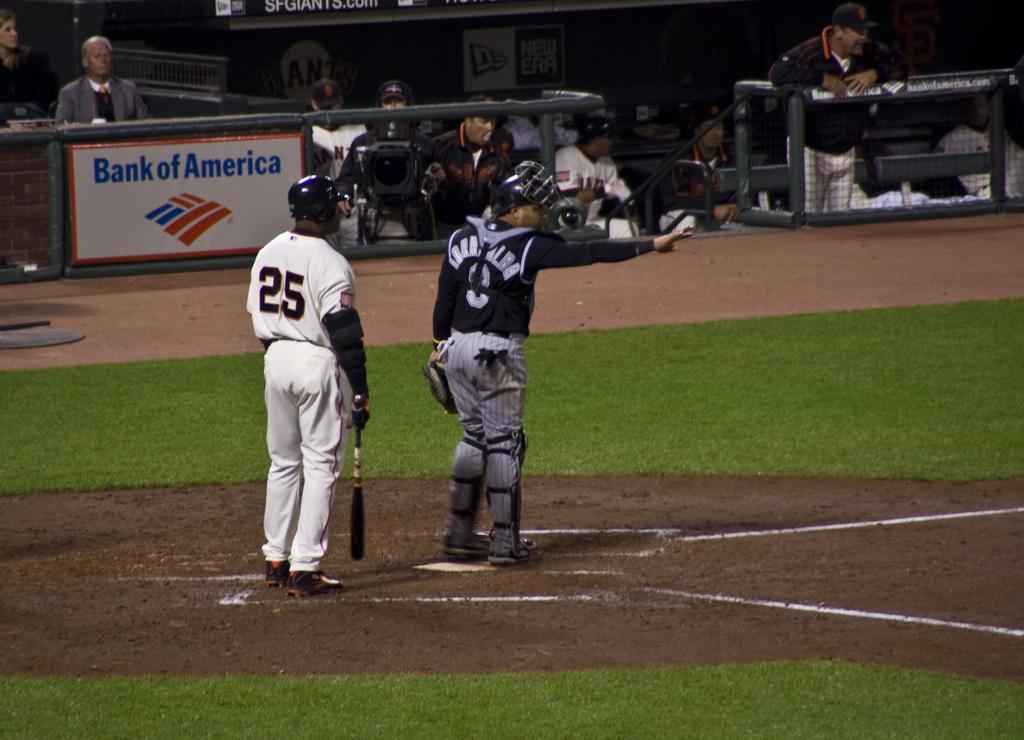Provide a one-sentence caption for the provided image. Bank of America is a donor to the baseball field. 